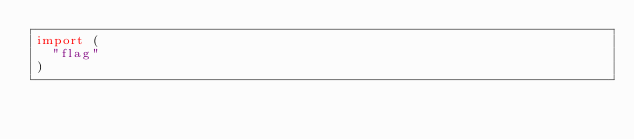Convert code to text. <code><loc_0><loc_0><loc_500><loc_500><_Go_>import (
	"flag"
)
</code> 